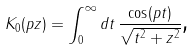Convert formula to latex. <formula><loc_0><loc_0><loc_500><loc_500>K _ { 0 } ( p z ) = \int _ { 0 } ^ { \infty } d t \, \frac { \cos ( p t ) } { \sqrt { t ^ { 2 } + z ^ { 2 } } } \text {,}</formula> 